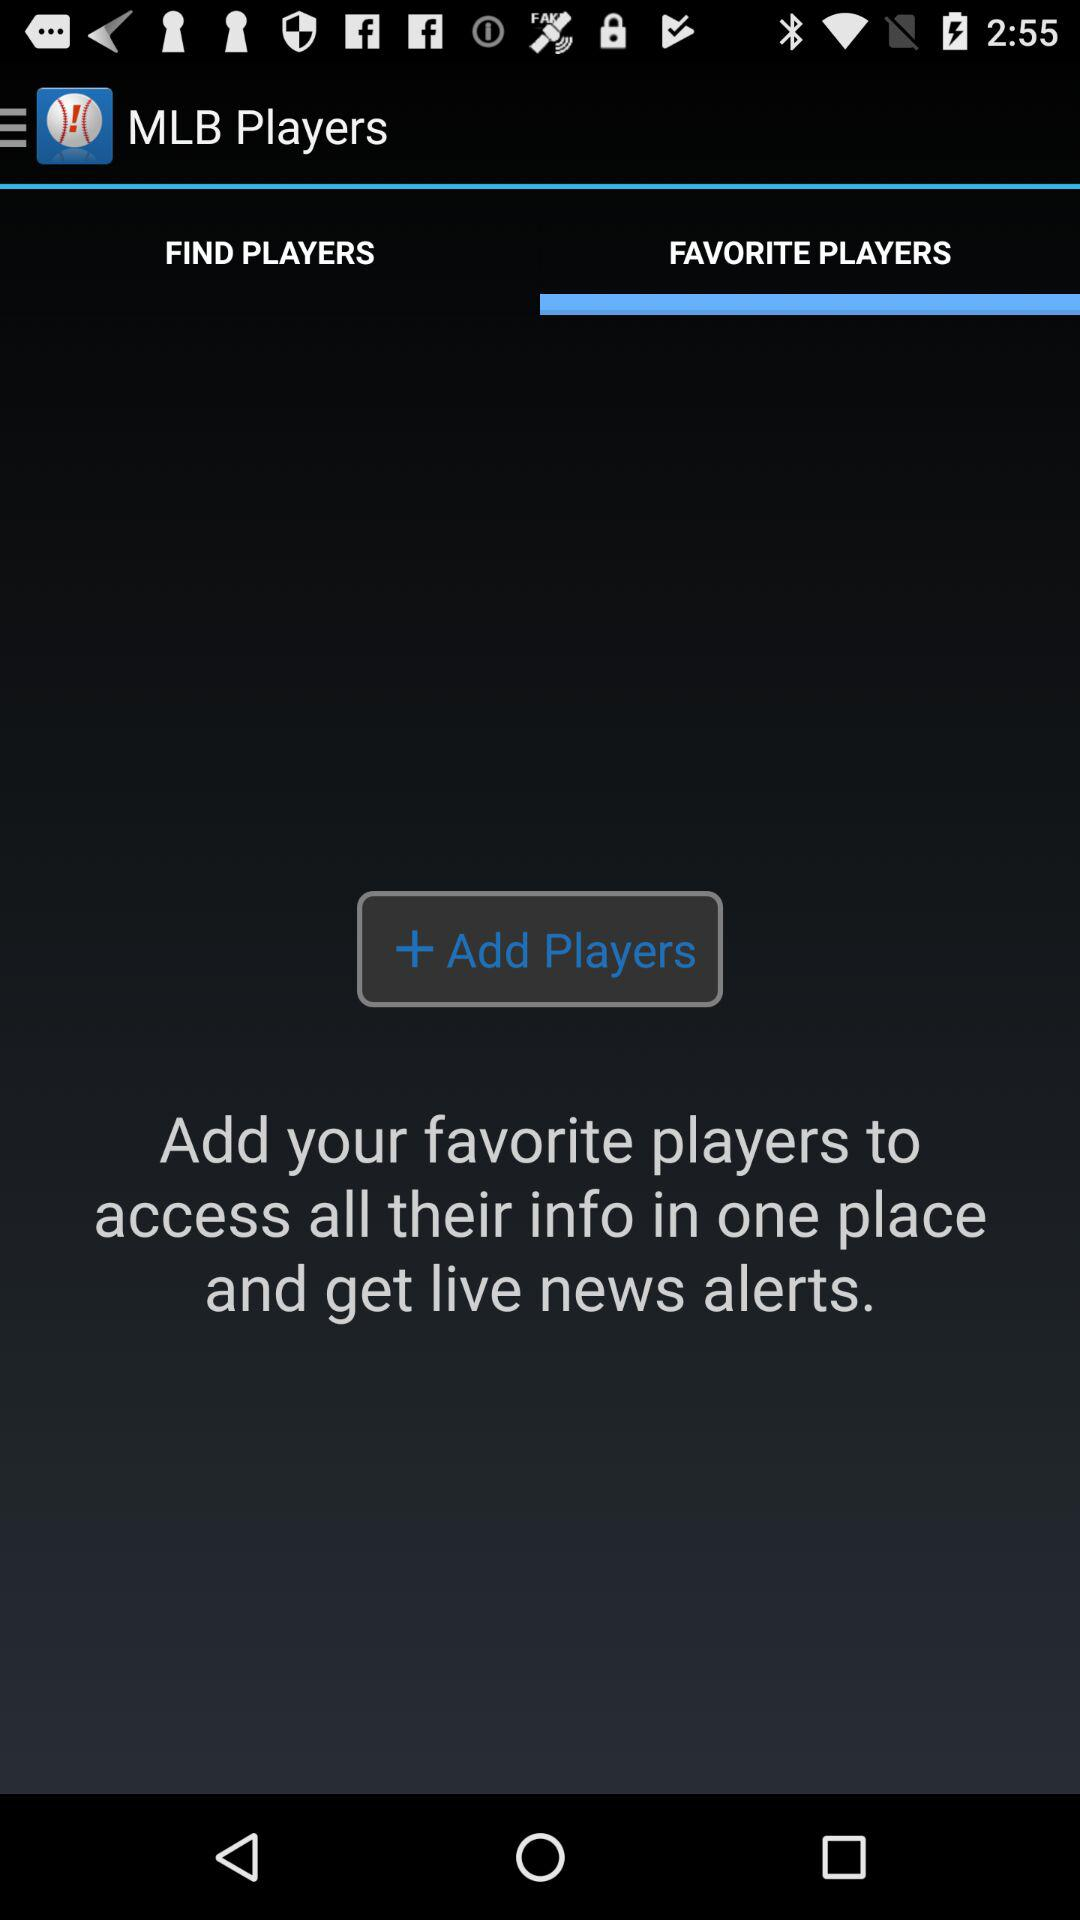Which tab is open? The open tab is "FAVORITE PLAYERS". 